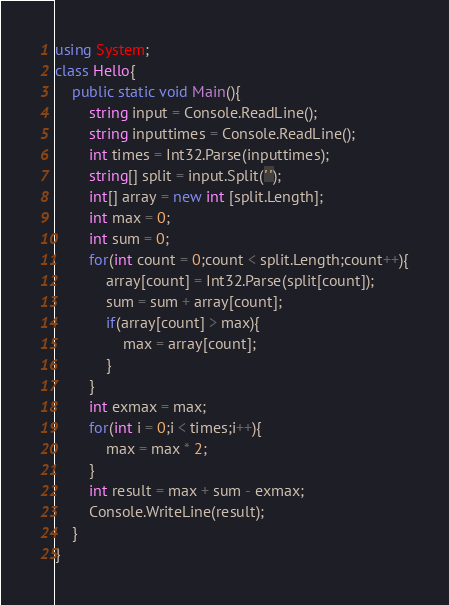Convert code to text. <code><loc_0><loc_0><loc_500><loc_500><_C#_>using System;
class Hello{
	public static void Main(){
		string input = Console.ReadLine();
		string inputtimes = Console.ReadLine();
		int times = Int32.Parse(inputtimes);
		string[] split = input.Split(' ');
		int[] array = new int [split.Length];
		int max = 0;
		int sum = 0;
		for(int count = 0;count < split.Length;count++){
			array[count] = Int32.Parse(split[count]);
			sum = sum + array[count];
			if(array[count] > max){
				max = array[count];
			}
		}
		int exmax = max;
		for(int i = 0;i < times;i++){
			max = max * 2;
		}
		int result = max + sum - exmax;
		Console.WriteLine(result);
	}
}
</code> 